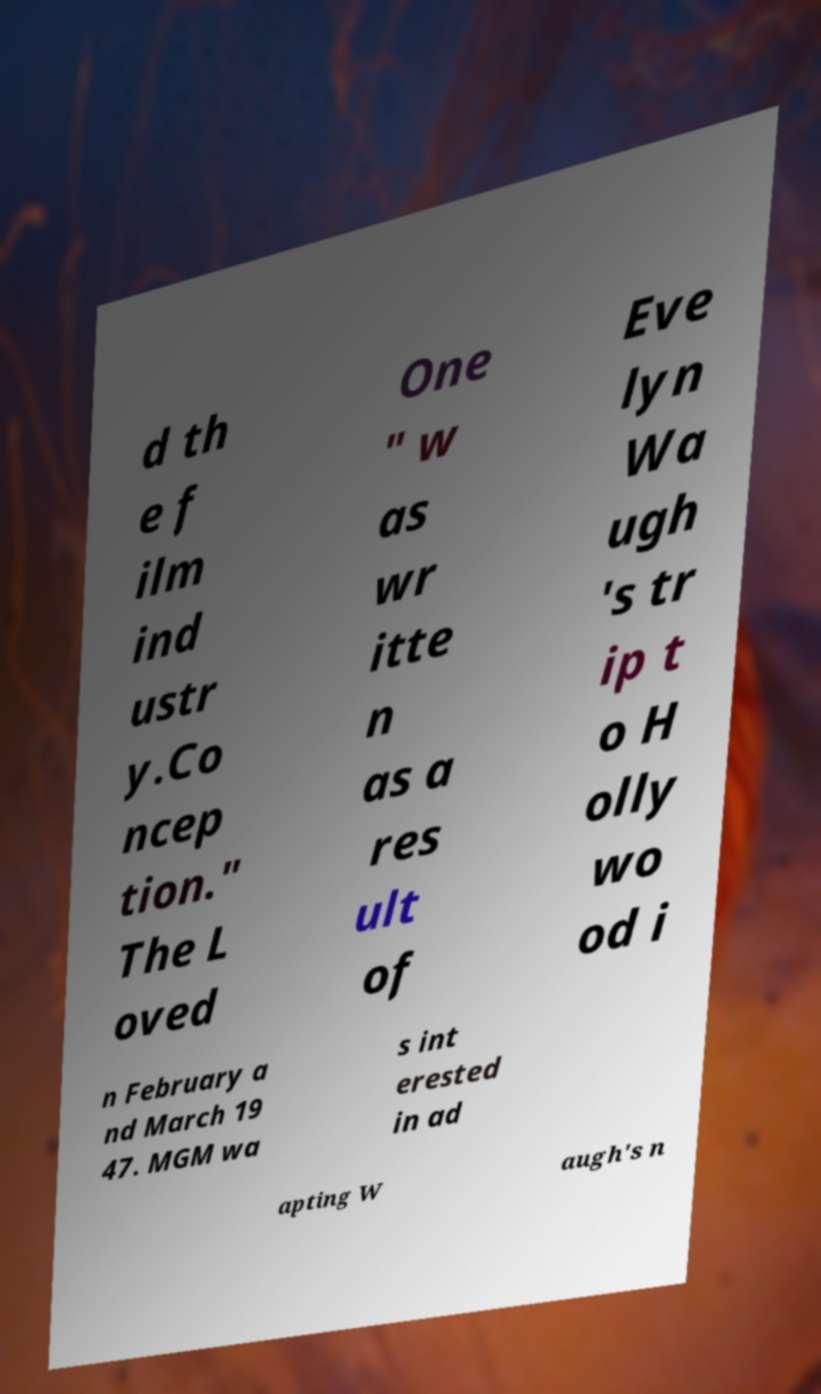What messages or text are displayed in this image? I need them in a readable, typed format. d th e f ilm ind ustr y.Co ncep tion." The L oved One " w as wr itte n as a res ult of Eve lyn Wa ugh 's tr ip t o H olly wo od i n February a nd March 19 47. MGM wa s int erested in ad apting W augh's n 